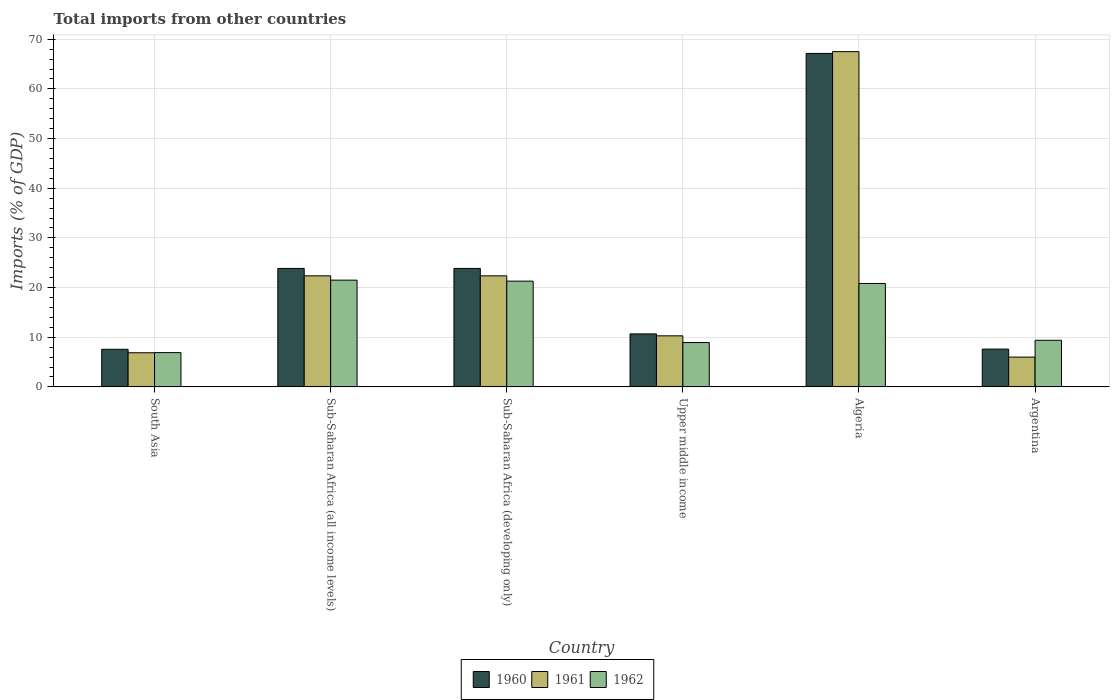How many bars are there on the 4th tick from the left?
Ensure brevity in your answer.  3. What is the total imports in 1960 in Algeria?
Provide a succinct answer. 67.14. Across all countries, what is the maximum total imports in 1960?
Your answer should be compact. 67.14. Across all countries, what is the minimum total imports in 1962?
Ensure brevity in your answer.  6.9. In which country was the total imports in 1960 maximum?
Ensure brevity in your answer.  Algeria. In which country was the total imports in 1960 minimum?
Provide a short and direct response. South Asia. What is the total total imports in 1962 in the graph?
Your answer should be very brief. 88.81. What is the difference between the total imports in 1961 in South Asia and that in Sub-Saharan Africa (all income levels)?
Keep it short and to the point. -15.49. What is the difference between the total imports in 1962 in Algeria and the total imports in 1961 in Sub-Saharan Africa (developing only)?
Provide a succinct answer. -1.54. What is the average total imports in 1961 per country?
Your response must be concise. 22.56. What is the difference between the total imports of/in 1962 and total imports of/in 1961 in Sub-Saharan Africa (all income levels)?
Your response must be concise. -0.87. What is the ratio of the total imports in 1961 in Argentina to that in Sub-Saharan Africa (all income levels)?
Your answer should be compact. 0.27. What is the difference between the highest and the second highest total imports in 1961?
Give a very brief answer. 45.14. What is the difference between the highest and the lowest total imports in 1960?
Your answer should be very brief. 59.57. Is the sum of the total imports in 1960 in Sub-Saharan Africa (all income levels) and Sub-Saharan Africa (developing only) greater than the maximum total imports in 1962 across all countries?
Provide a succinct answer. Yes. What does the 2nd bar from the left in South Asia represents?
Your response must be concise. 1961. What does the 1st bar from the right in Upper middle income represents?
Ensure brevity in your answer.  1962. What is the difference between two consecutive major ticks on the Y-axis?
Your response must be concise. 10. Are the values on the major ticks of Y-axis written in scientific E-notation?
Ensure brevity in your answer.  No. Does the graph contain any zero values?
Offer a very short reply. No. Does the graph contain grids?
Provide a short and direct response. Yes. What is the title of the graph?
Give a very brief answer. Total imports from other countries. What is the label or title of the Y-axis?
Provide a short and direct response. Imports (% of GDP). What is the Imports (% of GDP) in 1960 in South Asia?
Keep it short and to the point. 7.57. What is the Imports (% of GDP) of 1961 in South Asia?
Offer a terse response. 6.87. What is the Imports (% of GDP) in 1962 in South Asia?
Provide a short and direct response. 6.9. What is the Imports (% of GDP) of 1960 in Sub-Saharan Africa (all income levels)?
Make the answer very short. 23.85. What is the Imports (% of GDP) of 1961 in Sub-Saharan Africa (all income levels)?
Offer a very short reply. 22.36. What is the Imports (% of GDP) of 1962 in Sub-Saharan Africa (all income levels)?
Keep it short and to the point. 21.49. What is the Imports (% of GDP) in 1960 in Sub-Saharan Africa (developing only)?
Offer a terse response. 23.85. What is the Imports (% of GDP) of 1961 in Sub-Saharan Africa (developing only)?
Offer a terse response. 22.36. What is the Imports (% of GDP) in 1962 in Sub-Saharan Africa (developing only)?
Give a very brief answer. 21.29. What is the Imports (% of GDP) in 1960 in Upper middle income?
Ensure brevity in your answer.  10.67. What is the Imports (% of GDP) in 1961 in Upper middle income?
Your answer should be very brief. 10.28. What is the Imports (% of GDP) in 1962 in Upper middle income?
Your answer should be compact. 8.92. What is the Imports (% of GDP) of 1960 in Algeria?
Your response must be concise. 67.14. What is the Imports (% of GDP) in 1961 in Algeria?
Provide a short and direct response. 67.5. What is the Imports (% of GDP) of 1962 in Algeria?
Offer a very short reply. 20.82. What is the Imports (% of GDP) of 1960 in Argentina?
Offer a terse response. 7.6. What is the Imports (% of GDP) of 1961 in Argentina?
Give a very brief answer. 5.99. What is the Imports (% of GDP) in 1962 in Argentina?
Provide a succinct answer. 9.38. Across all countries, what is the maximum Imports (% of GDP) in 1960?
Make the answer very short. 67.14. Across all countries, what is the maximum Imports (% of GDP) of 1961?
Ensure brevity in your answer.  67.5. Across all countries, what is the maximum Imports (% of GDP) in 1962?
Offer a very short reply. 21.49. Across all countries, what is the minimum Imports (% of GDP) of 1960?
Your answer should be very brief. 7.57. Across all countries, what is the minimum Imports (% of GDP) in 1961?
Give a very brief answer. 5.99. Across all countries, what is the minimum Imports (% of GDP) of 1962?
Provide a succinct answer. 6.9. What is the total Imports (% of GDP) in 1960 in the graph?
Your answer should be very brief. 140.69. What is the total Imports (% of GDP) of 1961 in the graph?
Your answer should be compact. 135.36. What is the total Imports (% of GDP) of 1962 in the graph?
Provide a short and direct response. 88.81. What is the difference between the Imports (% of GDP) of 1960 in South Asia and that in Sub-Saharan Africa (all income levels)?
Provide a succinct answer. -16.28. What is the difference between the Imports (% of GDP) in 1961 in South Asia and that in Sub-Saharan Africa (all income levels)?
Offer a very short reply. -15.49. What is the difference between the Imports (% of GDP) in 1962 in South Asia and that in Sub-Saharan Africa (all income levels)?
Your response must be concise. -14.59. What is the difference between the Imports (% of GDP) of 1960 in South Asia and that in Sub-Saharan Africa (developing only)?
Ensure brevity in your answer.  -16.28. What is the difference between the Imports (% of GDP) in 1961 in South Asia and that in Sub-Saharan Africa (developing only)?
Your response must be concise. -15.49. What is the difference between the Imports (% of GDP) of 1962 in South Asia and that in Sub-Saharan Africa (developing only)?
Ensure brevity in your answer.  -14.39. What is the difference between the Imports (% of GDP) of 1960 in South Asia and that in Upper middle income?
Provide a short and direct response. -3.1. What is the difference between the Imports (% of GDP) in 1961 in South Asia and that in Upper middle income?
Your response must be concise. -3.41. What is the difference between the Imports (% of GDP) in 1962 in South Asia and that in Upper middle income?
Your response must be concise. -2.02. What is the difference between the Imports (% of GDP) of 1960 in South Asia and that in Algeria?
Provide a succinct answer. -59.57. What is the difference between the Imports (% of GDP) in 1961 in South Asia and that in Algeria?
Offer a very short reply. -60.63. What is the difference between the Imports (% of GDP) of 1962 in South Asia and that in Algeria?
Your response must be concise. -13.92. What is the difference between the Imports (% of GDP) in 1960 in South Asia and that in Argentina?
Your answer should be compact. -0.04. What is the difference between the Imports (% of GDP) in 1961 in South Asia and that in Argentina?
Ensure brevity in your answer.  0.88. What is the difference between the Imports (% of GDP) in 1962 in South Asia and that in Argentina?
Your response must be concise. -2.49. What is the difference between the Imports (% of GDP) of 1961 in Sub-Saharan Africa (all income levels) and that in Sub-Saharan Africa (developing only)?
Keep it short and to the point. 0. What is the difference between the Imports (% of GDP) of 1962 in Sub-Saharan Africa (all income levels) and that in Sub-Saharan Africa (developing only)?
Provide a short and direct response. 0.2. What is the difference between the Imports (% of GDP) of 1960 in Sub-Saharan Africa (all income levels) and that in Upper middle income?
Offer a terse response. 13.18. What is the difference between the Imports (% of GDP) in 1961 in Sub-Saharan Africa (all income levels) and that in Upper middle income?
Keep it short and to the point. 12.08. What is the difference between the Imports (% of GDP) in 1962 in Sub-Saharan Africa (all income levels) and that in Upper middle income?
Offer a terse response. 12.57. What is the difference between the Imports (% of GDP) in 1960 in Sub-Saharan Africa (all income levels) and that in Algeria?
Keep it short and to the point. -43.29. What is the difference between the Imports (% of GDP) in 1961 in Sub-Saharan Africa (all income levels) and that in Algeria?
Offer a terse response. -45.14. What is the difference between the Imports (% of GDP) in 1962 in Sub-Saharan Africa (all income levels) and that in Algeria?
Your response must be concise. 0.67. What is the difference between the Imports (% of GDP) of 1960 in Sub-Saharan Africa (all income levels) and that in Argentina?
Keep it short and to the point. 16.25. What is the difference between the Imports (% of GDP) in 1961 in Sub-Saharan Africa (all income levels) and that in Argentina?
Offer a terse response. 16.36. What is the difference between the Imports (% of GDP) in 1962 in Sub-Saharan Africa (all income levels) and that in Argentina?
Provide a succinct answer. 12.11. What is the difference between the Imports (% of GDP) in 1960 in Sub-Saharan Africa (developing only) and that in Upper middle income?
Provide a short and direct response. 13.18. What is the difference between the Imports (% of GDP) of 1961 in Sub-Saharan Africa (developing only) and that in Upper middle income?
Your answer should be compact. 12.08. What is the difference between the Imports (% of GDP) in 1962 in Sub-Saharan Africa (developing only) and that in Upper middle income?
Make the answer very short. 12.37. What is the difference between the Imports (% of GDP) in 1960 in Sub-Saharan Africa (developing only) and that in Algeria?
Make the answer very short. -43.29. What is the difference between the Imports (% of GDP) of 1961 in Sub-Saharan Africa (developing only) and that in Algeria?
Give a very brief answer. -45.14. What is the difference between the Imports (% of GDP) of 1962 in Sub-Saharan Africa (developing only) and that in Algeria?
Keep it short and to the point. 0.47. What is the difference between the Imports (% of GDP) in 1960 in Sub-Saharan Africa (developing only) and that in Argentina?
Your response must be concise. 16.25. What is the difference between the Imports (% of GDP) in 1961 in Sub-Saharan Africa (developing only) and that in Argentina?
Give a very brief answer. 16.36. What is the difference between the Imports (% of GDP) in 1962 in Sub-Saharan Africa (developing only) and that in Argentina?
Offer a very short reply. 11.91. What is the difference between the Imports (% of GDP) of 1960 in Upper middle income and that in Algeria?
Offer a very short reply. -56.48. What is the difference between the Imports (% of GDP) in 1961 in Upper middle income and that in Algeria?
Provide a short and direct response. -57.23. What is the difference between the Imports (% of GDP) of 1962 in Upper middle income and that in Algeria?
Offer a terse response. -11.9. What is the difference between the Imports (% of GDP) in 1960 in Upper middle income and that in Argentina?
Keep it short and to the point. 3.06. What is the difference between the Imports (% of GDP) of 1961 in Upper middle income and that in Argentina?
Your response must be concise. 4.28. What is the difference between the Imports (% of GDP) in 1962 in Upper middle income and that in Argentina?
Offer a terse response. -0.46. What is the difference between the Imports (% of GDP) in 1960 in Algeria and that in Argentina?
Offer a very short reply. 59.54. What is the difference between the Imports (% of GDP) of 1961 in Algeria and that in Argentina?
Provide a short and direct response. 61.51. What is the difference between the Imports (% of GDP) in 1962 in Algeria and that in Argentina?
Your response must be concise. 11.44. What is the difference between the Imports (% of GDP) of 1960 in South Asia and the Imports (% of GDP) of 1961 in Sub-Saharan Africa (all income levels)?
Your answer should be very brief. -14.79. What is the difference between the Imports (% of GDP) in 1960 in South Asia and the Imports (% of GDP) in 1962 in Sub-Saharan Africa (all income levels)?
Offer a terse response. -13.92. What is the difference between the Imports (% of GDP) in 1961 in South Asia and the Imports (% of GDP) in 1962 in Sub-Saharan Africa (all income levels)?
Keep it short and to the point. -14.62. What is the difference between the Imports (% of GDP) in 1960 in South Asia and the Imports (% of GDP) in 1961 in Sub-Saharan Africa (developing only)?
Your answer should be very brief. -14.79. What is the difference between the Imports (% of GDP) of 1960 in South Asia and the Imports (% of GDP) of 1962 in Sub-Saharan Africa (developing only)?
Provide a succinct answer. -13.72. What is the difference between the Imports (% of GDP) in 1961 in South Asia and the Imports (% of GDP) in 1962 in Sub-Saharan Africa (developing only)?
Your answer should be compact. -14.42. What is the difference between the Imports (% of GDP) of 1960 in South Asia and the Imports (% of GDP) of 1961 in Upper middle income?
Ensure brevity in your answer.  -2.71. What is the difference between the Imports (% of GDP) in 1960 in South Asia and the Imports (% of GDP) in 1962 in Upper middle income?
Your response must be concise. -1.35. What is the difference between the Imports (% of GDP) in 1961 in South Asia and the Imports (% of GDP) in 1962 in Upper middle income?
Your answer should be compact. -2.05. What is the difference between the Imports (% of GDP) in 1960 in South Asia and the Imports (% of GDP) in 1961 in Algeria?
Your response must be concise. -59.93. What is the difference between the Imports (% of GDP) of 1960 in South Asia and the Imports (% of GDP) of 1962 in Algeria?
Ensure brevity in your answer.  -13.25. What is the difference between the Imports (% of GDP) in 1961 in South Asia and the Imports (% of GDP) in 1962 in Algeria?
Keep it short and to the point. -13.95. What is the difference between the Imports (% of GDP) in 1960 in South Asia and the Imports (% of GDP) in 1961 in Argentina?
Your response must be concise. 1.57. What is the difference between the Imports (% of GDP) of 1960 in South Asia and the Imports (% of GDP) of 1962 in Argentina?
Provide a succinct answer. -1.81. What is the difference between the Imports (% of GDP) of 1961 in South Asia and the Imports (% of GDP) of 1962 in Argentina?
Offer a very short reply. -2.51. What is the difference between the Imports (% of GDP) of 1960 in Sub-Saharan Africa (all income levels) and the Imports (% of GDP) of 1961 in Sub-Saharan Africa (developing only)?
Offer a terse response. 1.49. What is the difference between the Imports (% of GDP) in 1960 in Sub-Saharan Africa (all income levels) and the Imports (% of GDP) in 1962 in Sub-Saharan Africa (developing only)?
Ensure brevity in your answer.  2.56. What is the difference between the Imports (% of GDP) in 1961 in Sub-Saharan Africa (all income levels) and the Imports (% of GDP) in 1962 in Sub-Saharan Africa (developing only)?
Ensure brevity in your answer.  1.07. What is the difference between the Imports (% of GDP) of 1960 in Sub-Saharan Africa (all income levels) and the Imports (% of GDP) of 1961 in Upper middle income?
Offer a very short reply. 13.58. What is the difference between the Imports (% of GDP) of 1960 in Sub-Saharan Africa (all income levels) and the Imports (% of GDP) of 1962 in Upper middle income?
Offer a very short reply. 14.93. What is the difference between the Imports (% of GDP) in 1961 in Sub-Saharan Africa (all income levels) and the Imports (% of GDP) in 1962 in Upper middle income?
Your answer should be very brief. 13.44. What is the difference between the Imports (% of GDP) of 1960 in Sub-Saharan Africa (all income levels) and the Imports (% of GDP) of 1961 in Algeria?
Give a very brief answer. -43.65. What is the difference between the Imports (% of GDP) of 1960 in Sub-Saharan Africa (all income levels) and the Imports (% of GDP) of 1962 in Algeria?
Your answer should be compact. 3.03. What is the difference between the Imports (% of GDP) in 1961 in Sub-Saharan Africa (all income levels) and the Imports (% of GDP) in 1962 in Algeria?
Make the answer very short. 1.54. What is the difference between the Imports (% of GDP) in 1960 in Sub-Saharan Africa (all income levels) and the Imports (% of GDP) in 1961 in Argentina?
Keep it short and to the point. 17.86. What is the difference between the Imports (% of GDP) in 1960 in Sub-Saharan Africa (all income levels) and the Imports (% of GDP) in 1962 in Argentina?
Your response must be concise. 14.47. What is the difference between the Imports (% of GDP) of 1961 in Sub-Saharan Africa (all income levels) and the Imports (% of GDP) of 1962 in Argentina?
Provide a short and direct response. 12.98. What is the difference between the Imports (% of GDP) in 1960 in Sub-Saharan Africa (developing only) and the Imports (% of GDP) in 1961 in Upper middle income?
Your answer should be compact. 13.58. What is the difference between the Imports (% of GDP) of 1960 in Sub-Saharan Africa (developing only) and the Imports (% of GDP) of 1962 in Upper middle income?
Offer a terse response. 14.93. What is the difference between the Imports (% of GDP) of 1961 in Sub-Saharan Africa (developing only) and the Imports (% of GDP) of 1962 in Upper middle income?
Offer a very short reply. 13.44. What is the difference between the Imports (% of GDP) of 1960 in Sub-Saharan Africa (developing only) and the Imports (% of GDP) of 1961 in Algeria?
Offer a terse response. -43.65. What is the difference between the Imports (% of GDP) in 1960 in Sub-Saharan Africa (developing only) and the Imports (% of GDP) in 1962 in Algeria?
Make the answer very short. 3.03. What is the difference between the Imports (% of GDP) of 1961 in Sub-Saharan Africa (developing only) and the Imports (% of GDP) of 1962 in Algeria?
Offer a terse response. 1.54. What is the difference between the Imports (% of GDP) of 1960 in Sub-Saharan Africa (developing only) and the Imports (% of GDP) of 1961 in Argentina?
Your answer should be compact. 17.86. What is the difference between the Imports (% of GDP) of 1960 in Sub-Saharan Africa (developing only) and the Imports (% of GDP) of 1962 in Argentina?
Your answer should be very brief. 14.47. What is the difference between the Imports (% of GDP) in 1961 in Sub-Saharan Africa (developing only) and the Imports (% of GDP) in 1962 in Argentina?
Offer a terse response. 12.98. What is the difference between the Imports (% of GDP) in 1960 in Upper middle income and the Imports (% of GDP) in 1961 in Algeria?
Offer a terse response. -56.84. What is the difference between the Imports (% of GDP) in 1960 in Upper middle income and the Imports (% of GDP) in 1962 in Algeria?
Provide a succinct answer. -10.15. What is the difference between the Imports (% of GDP) in 1961 in Upper middle income and the Imports (% of GDP) in 1962 in Algeria?
Your answer should be compact. -10.54. What is the difference between the Imports (% of GDP) in 1960 in Upper middle income and the Imports (% of GDP) in 1961 in Argentina?
Your answer should be very brief. 4.67. What is the difference between the Imports (% of GDP) in 1960 in Upper middle income and the Imports (% of GDP) in 1962 in Argentina?
Offer a terse response. 1.28. What is the difference between the Imports (% of GDP) in 1961 in Upper middle income and the Imports (% of GDP) in 1962 in Argentina?
Keep it short and to the point. 0.89. What is the difference between the Imports (% of GDP) in 1960 in Algeria and the Imports (% of GDP) in 1961 in Argentina?
Make the answer very short. 61.15. What is the difference between the Imports (% of GDP) of 1960 in Algeria and the Imports (% of GDP) of 1962 in Argentina?
Provide a succinct answer. 57.76. What is the difference between the Imports (% of GDP) of 1961 in Algeria and the Imports (% of GDP) of 1962 in Argentina?
Provide a succinct answer. 58.12. What is the average Imports (% of GDP) in 1960 per country?
Your response must be concise. 23.45. What is the average Imports (% of GDP) of 1961 per country?
Provide a succinct answer. 22.56. What is the average Imports (% of GDP) in 1962 per country?
Provide a succinct answer. 14.8. What is the difference between the Imports (% of GDP) in 1960 and Imports (% of GDP) in 1961 in South Asia?
Keep it short and to the point. 0.7. What is the difference between the Imports (% of GDP) of 1960 and Imports (% of GDP) of 1962 in South Asia?
Provide a short and direct response. 0.67. What is the difference between the Imports (% of GDP) in 1961 and Imports (% of GDP) in 1962 in South Asia?
Offer a terse response. -0.03. What is the difference between the Imports (% of GDP) of 1960 and Imports (% of GDP) of 1961 in Sub-Saharan Africa (all income levels)?
Keep it short and to the point. 1.49. What is the difference between the Imports (% of GDP) in 1960 and Imports (% of GDP) in 1962 in Sub-Saharan Africa (all income levels)?
Keep it short and to the point. 2.36. What is the difference between the Imports (% of GDP) of 1961 and Imports (% of GDP) of 1962 in Sub-Saharan Africa (all income levels)?
Provide a short and direct response. 0.87. What is the difference between the Imports (% of GDP) in 1960 and Imports (% of GDP) in 1961 in Sub-Saharan Africa (developing only)?
Your answer should be very brief. 1.49. What is the difference between the Imports (% of GDP) of 1960 and Imports (% of GDP) of 1962 in Sub-Saharan Africa (developing only)?
Make the answer very short. 2.56. What is the difference between the Imports (% of GDP) in 1961 and Imports (% of GDP) in 1962 in Sub-Saharan Africa (developing only)?
Make the answer very short. 1.07. What is the difference between the Imports (% of GDP) of 1960 and Imports (% of GDP) of 1961 in Upper middle income?
Provide a succinct answer. 0.39. What is the difference between the Imports (% of GDP) in 1960 and Imports (% of GDP) in 1962 in Upper middle income?
Your answer should be compact. 1.75. What is the difference between the Imports (% of GDP) of 1961 and Imports (% of GDP) of 1962 in Upper middle income?
Offer a terse response. 1.35. What is the difference between the Imports (% of GDP) of 1960 and Imports (% of GDP) of 1961 in Algeria?
Your answer should be compact. -0.36. What is the difference between the Imports (% of GDP) of 1960 and Imports (% of GDP) of 1962 in Algeria?
Give a very brief answer. 46.33. What is the difference between the Imports (% of GDP) in 1961 and Imports (% of GDP) in 1962 in Algeria?
Make the answer very short. 46.69. What is the difference between the Imports (% of GDP) of 1960 and Imports (% of GDP) of 1961 in Argentina?
Your answer should be compact. 1.61. What is the difference between the Imports (% of GDP) of 1960 and Imports (% of GDP) of 1962 in Argentina?
Your response must be concise. -1.78. What is the difference between the Imports (% of GDP) of 1961 and Imports (% of GDP) of 1962 in Argentina?
Ensure brevity in your answer.  -3.39. What is the ratio of the Imports (% of GDP) of 1960 in South Asia to that in Sub-Saharan Africa (all income levels)?
Your response must be concise. 0.32. What is the ratio of the Imports (% of GDP) of 1961 in South Asia to that in Sub-Saharan Africa (all income levels)?
Offer a terse response. 0.31. What is the ratio of the Imports (% of GDP) in 1962 in South Asia to that in Sub-Saharan Africa (all income levels)?
Your answer should be very brief. 0.32. What is the ratio of the Imports (% of GDP) of 1960 in South Asia to that in Sub-Saharan Africa (developing only)?
Your response must be concise. 0.32. What is the ratio of the Imports (% of GDP) of 1961 in South Asia to that in Sub-Saharan Africa (developing only)?
Provide a succinct answer. 0.31. What is the ratio of the Imports (% of GDP) in 1962 in South Asia to that in Sub-Saharan Africa (developing only)?
Offer a terse response. 0.32. What is the ratio of the Imports (% of GDP) of 1960 in South Asia to that in Upper middle income?
Your response must be concise. 0.71. What is the ratio of the Imports (% of GDP) in 1961 in South Asia to that in Upper middle income?
Offer a terse response. 0.67. What is the ratio of the Imports (% of GDP) in 1962 in South Asia to that in Upper middle income?
Keep it short and to the point. 0.77. What is the ratio of the Imports (% of GDP) in 1960 in South Asia to that in Algeria?
Ensure brevity in your answer.  0.11. What is the ratio of the Imports (% of GDP) in 1961 in South Asia to that in Algeria?
Your response must be concise. 0.1. What is the ratio of the Imports (% of GDP) of 1962 in South Asia to that in Algeria?
Make the answer very short. 0.33. What is the ratio of the Imports (% of GDP) in 1960 in South Asia to that in Argentina?
Offer a very short reply. 1. What is the ratio of the Imports (% of GDP) in 1961 in South Asia to that in Argentina?
Your answer should be very brief. 1.15. What is the ratio of the Imports (% of GDP) in 1962 in South Asia to that in Argentina?
Keep it short and to the point. 0.74. What is the ratio of the Imports (% of GDP) of 1961 in Sub-Saharan Africa (all income levels) to that in Sub-Saharan Africa (developing only)?
Your answer should be compact. 1. What is the ratio of the Imports (% of GDP) in 1962 in Sub-Saharan Africa (all income levels) to that in Sub-Saharan Africa (developing only)?
Give a very brief answer. 1.01. What is the ratio of the Imports (% of GDP) in 1960 in Sub-Saharan Africa (all income levels) to that in Upper middle income?
Your answer should be very brief. 2.24. What is the ratio of the Imports (% of GDP) of 1961 in Sub-Saharan Africa (all income levels) to that in Upper middle income?
Provide a short and direct response. 2.18. What is the ratio of the Imports (% of GDP) in 1962 in Sub-Saharan Africa (all income levels) to that in Upper middle income?
Your answer should be very brief. 2.41. What is the ratio of the Imports (% of GDP) of 1960 in Sub-Saharan Africa (all income levels) to that in Algeria?
Provide a short and direct response. 0.36. What is the ratio of the Imports (% of GDP) in 1961 in Sub-Saharan Africa (all income levels) to that in Algeria?
Offer a terse response. 0.33. What is the ratio of the Imports (% of GDP) in 1962 in Sub-Saharan Africa (all income levels) to that in Algeria?
Provide a short and direct response. 1.03. What is the ratio of the Imports (% of GDP) in 1960 in Sub-Saharan Africa (all income levels) to that in Argentina?
Your answer should be very brief. 3.14. What is the ratio of the Imports (% of GDP) of 1961 in Sub-Saharan Africa (all income levels) to that in Argentina?
Ensure brevity in your answer.  3.73. What is the ratio of the Imports (% of GDP) in 1962 in Sub-Saharan Africa (all income levels) to that in Argentina?
Your answer should be compact. 2.29. What is the ratio of the Imports (% of GDP) in 1960 in Sub-Saharan Africa (developing only) to that in Upper middle income?
Your response must be concise. 2.24. What is the ratio of the Imports (% of GDP) of 1961 in Sub-Saharan Africa (developing only) to that in Upper middle income?
Offer a very short reply. 2.18. What is the ratio of the Imports (% of GDP) of 1962 in Sub-Saharan Africa (developing only) to that in Upper middle income?
Your answer should be compact. 2.39. What is the ratio of the Imports (% of GDP) in 1960 in Sub-Saharan Africa (developing only) to that in Algeria?
Make the answer very short. 0.36. What is the ratio of the Imports (% of GDP) of 1961 in Sub-Saharan Africa (developing only) to that in Algeria?
Give a very brief answer. 0.33. What is the ratio of the Imports (% of GDP) of 1962 in Sub-Saharan Africa (developing only) to that in Algeria?
Your response must be concise. 1.02. What is the ratio of the Imports (% of GDP) of 1960 in Sub-Saharan Africa (developing only) to that in Argentina?
Your response must be concise. 3.14. What is the ratio of the Imports (% of GDP) of 1961 in Sub-Saharan Africa (developing only) to that in Argentina?
Your response must be concise. 3.73. What is the ratio of the Imports (% of GDP) of 1962 in Sub-Saharan Africa (developing only) to that in Argentina?
Offer a terse response. 2.27. What is the ratio of the Imports (% of GDP) in 1960 in Upper middle income to that in Algeria?
Your answer should be very brief. 0.16. What is the ratio of the Imports (% of GDP) of 1961 in Upper middle income to that in Algeria?
Offer a terse response. 0.15. What is the ratio of the Imports (% of GDP) in 1962 in Upper middle income to that in Algeria?
Provide a short and direct response. 0.43. What is the ratio of the Imports (% of GDP) of 1960 in Upper middle income to that in Argentina?
Give a very brief answer. 1.4. What is the ratio of the Imports (% of GDP) in 1961 in Upper middle income to that in Argentina?
Offer a terse response. 1.71. What is the ratio of the Imports (% of GDP) of 1962 in Upper middle income to that in Argentina?
Your answer should be very brief. 0.95. What is the ratio of the Imports (% of GDP) of 1960 in Algeria to that in Argentina?
Your response must be concise. 8.83. What is the ratio of the Imports (% of GDP) in 1961 in Algeria to that in Argentina?
Provide a short and direct response. 11.26. What is the ratio of the Imports (% of GDP) in 1962 in Algeria to that in Argentina?
Your answer should be compact. 2.22. What is the difference between the highest and the second highest Imports (% of GDP) in 1960?
Offer a very short reply. 43.29. What is the difference between the highest and the second highest Imports (% of GDP) in 1961?
Keep it short and to the point. 45.14. What is the difference between the highest and the second highest Imports (% of GDP) in 1962?
Provide a short and direct response. 0.2. What is the difference between the highest and the lowest Imports (% of GDP) in 1960?
Provide a succinct answer. 59.57. What is the difference between the highest and the lowest Imports (% of GDP) of 1961?
Keep it short and to the point. 61.51. What is the difference between the highest and the lowest Imports (% of GDP) of 1962?
Your answer should be very brief. 14.59. 